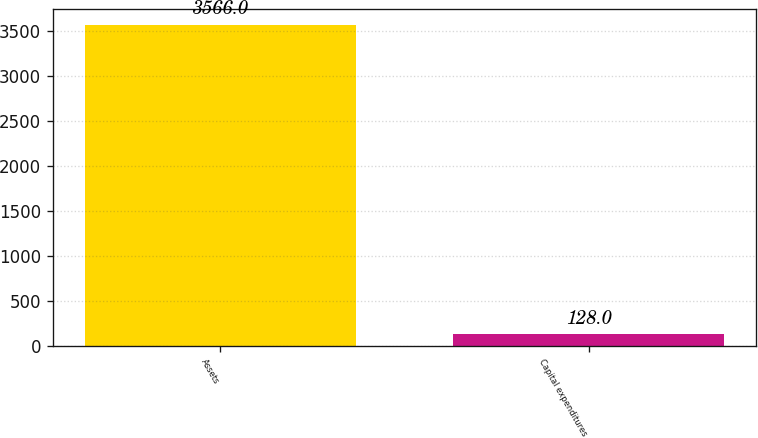<chart> <loc_0><loc_0><loc_500><loc_500><bar_chart><fcel>Assets<fcel>Capital expenditures<nl><fcel>3566<fcel>128<nl></chart> 